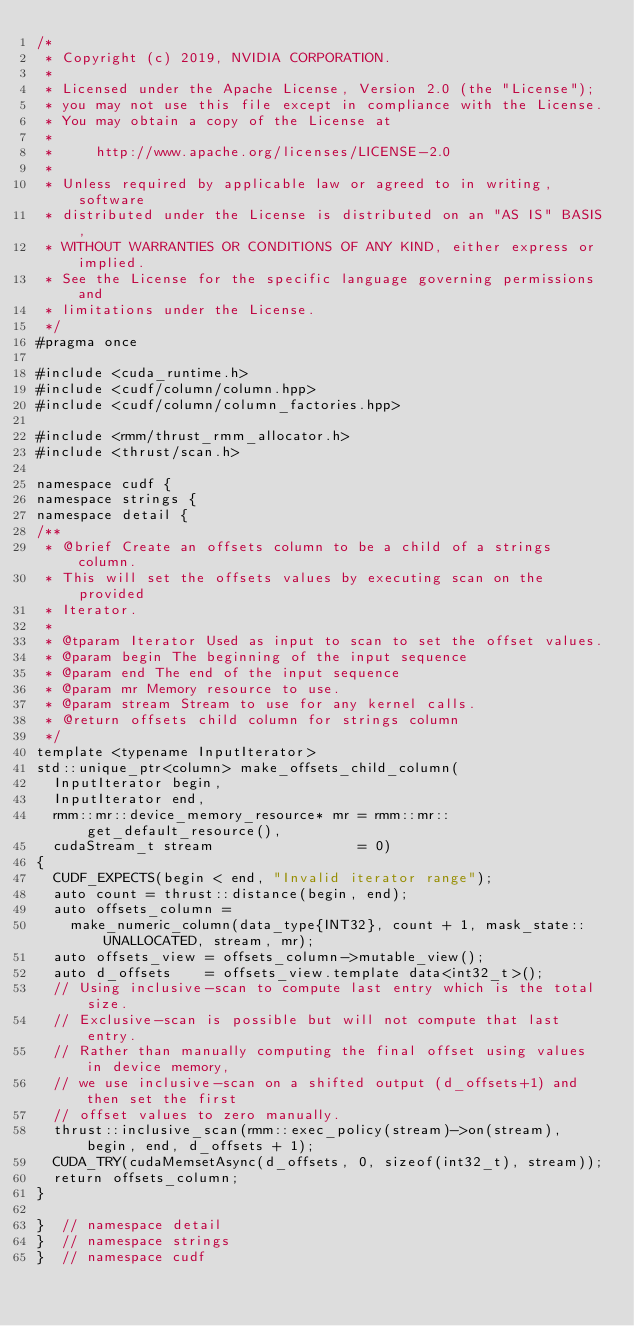<code> <loc_0><loc_0><loc_500><loc_500><_Cuda_>/*
 * Copyright (c) 2019, NVIDIA CORPORATION.
 *
 * Licensed under the Apache License, Version 2.0 (the "License");
 * you may not use this file except in compliance with the License.
 * You may obtain a copy of the License at
 *
 *     http://www.apache.org/licenses/LICENSE-2.0
 *
 * Unless required by applicable law or agreed to in writing, software
 * distributed under the License is distributed on an "AS IS" BASIS,
 * WITHOUT WARRANTIES OR CONDITIONS OF ANY KIND, either express or implied.
 * See the License for the specific language governing permissions and
 * limitations under the License.
 */
#pragma once

#include <cuda_runtime.h>
#include <cudf/column/column.hpp>
#include <cudf/column/column_factories.hpp>

#include <rmm/thrust_rmm_allocator.h>
#include <thrust/scan.h>

namespace cudf {
namespace strings {
namespace detail {
/**
 * @brief Create an offsets column to be a child of a strings column.
 * This will set the offsets values by executing scan on the provided
 * Iterator.
 *
 * @tparam Iterator Used as input to scan to set the offset values.
 * @param begin The beginning of the input sequence
 * @param end The end of the input sequence
 * @param mr Memory resource to use.
 * @param stream Stream to use for any kernel calls.
 * @return offsets child column for strings column
 */
template <typename InputIterator>
std::unique_ptr<column> make_offsets_child_column(
  InputIterator begin,
  InputIterator end,
  rmm::mr::device_memory_resource* mr = rmm::mr::get_default_resource(),
  cudaStream_t stream                 = 0)
{
  CUDF_EXPECTS(begin < end, "Invalid iterator range");
  auto count = thrust::distance(begin, end);
  auto offsets_column =
    make_numeric_column(data_type{INT32}, count + 1, mask_state::UNALLOCATED, stream, mr);
  auto offsets_view = offsets_column->mutable_view();
  auto d_offsets    = offsets_view.template data<int32_t>();
  // Using inclusive-scan to compute last entry which is the total size.
  // Exclusive-scan is possible but will not compute that last entry.
  // Rather than manually computing the final offset using values in device memory,
  // we use inclusive-scan on a shifted output (d_offsets+1) and then set the first
  // offset values to zero manually.
  thrust::inclusive_scan(rmm::exec_policy(stream)->on(stream), begin, end, d_offsets + 1);
  CUDA_TRY(cudaMemsetAsync(d_offsets, 0, sizeof(int32_t), stream));
  return offsets_column;
}

}  // namespace detail
}  // namespace strings
}  // namespace cudf
</code> 